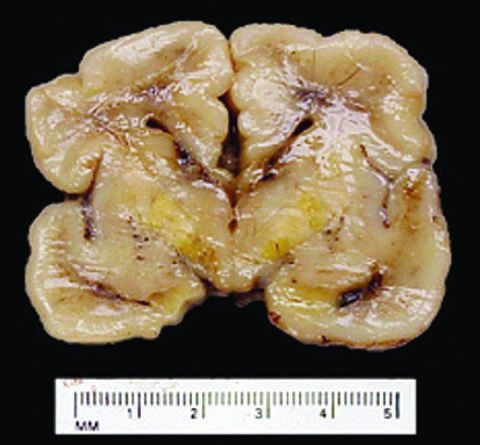does the cause of reversible injury occur because the blood-brain barrier is less developed in the neonatal period than it is in adulthood?
Answer the question using a single word or phrase. No 